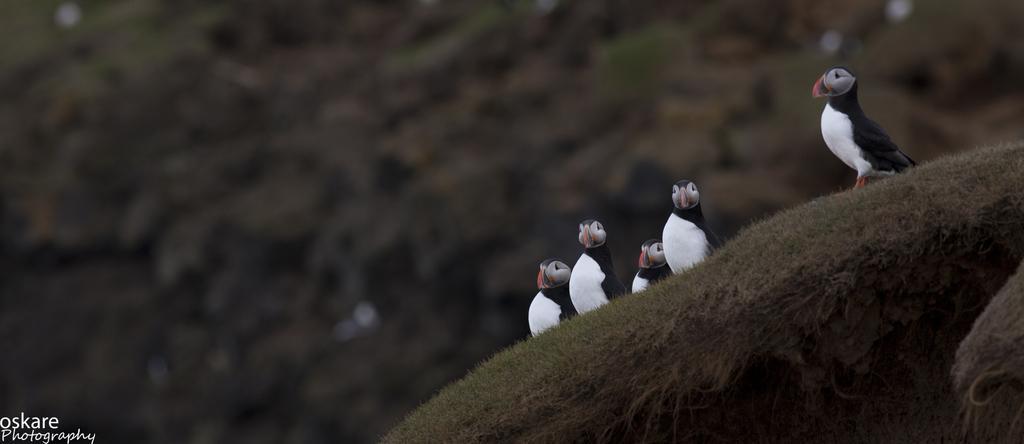Please provide a concise description of this image. In this image on the right side there is grass, and on the grass there are some birds and there is a blurry background. 